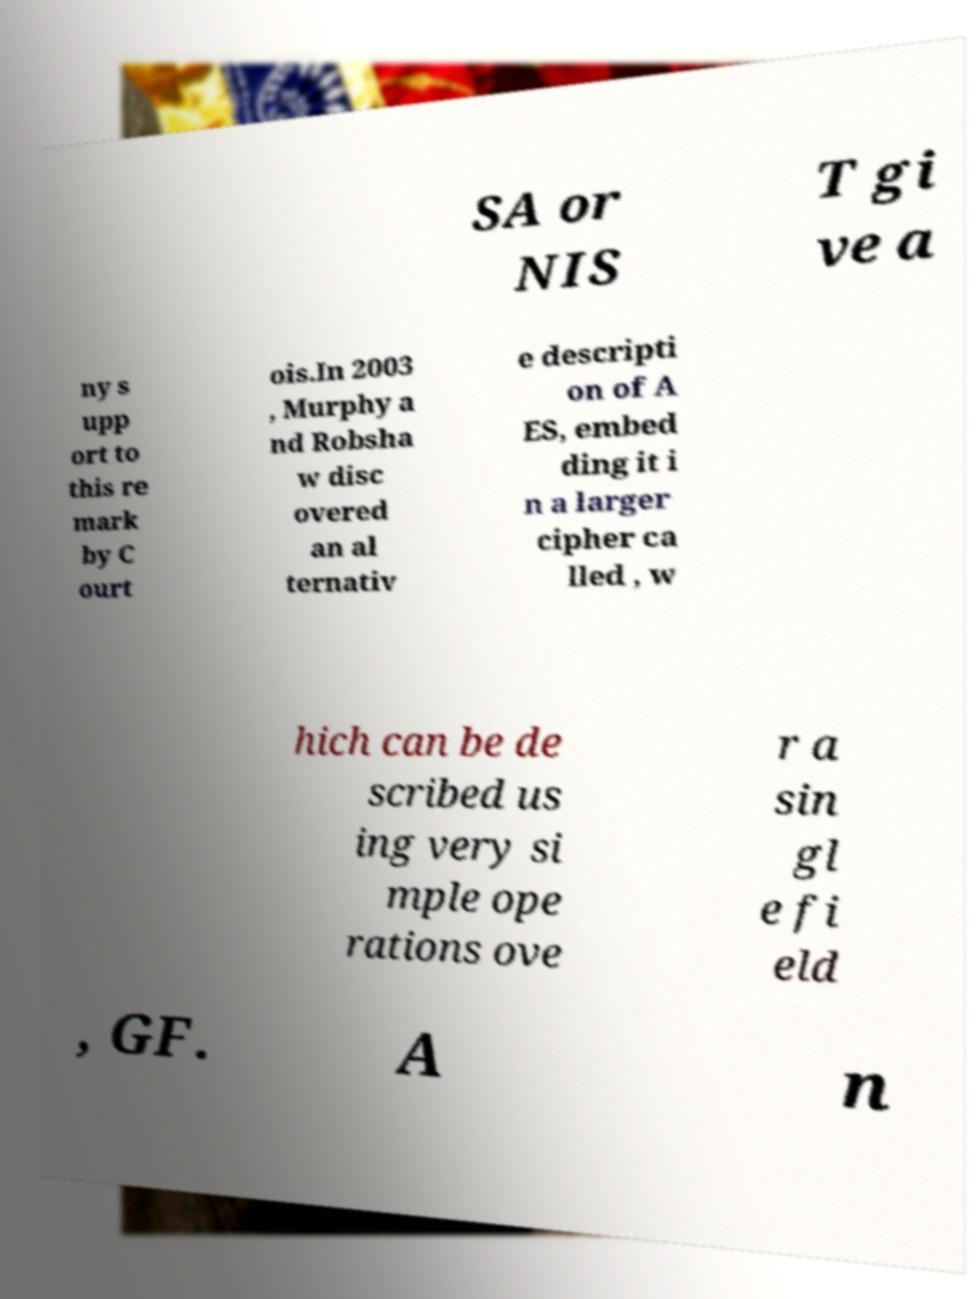What messages or text are displayed in this image? I need them in a readable, typed format. SA or NIS T gi ve a ny s upp ort to this re mark by C ourt ois.In 2003 , Murphy a nd Robsha w disc overed an al ternativ e descripti on of A ES, embed ding it i n a larger cipher ca lled , w hich can be de scribed us ing very si mple ope rations ove r a sin gl e fi eld , GF. A n 